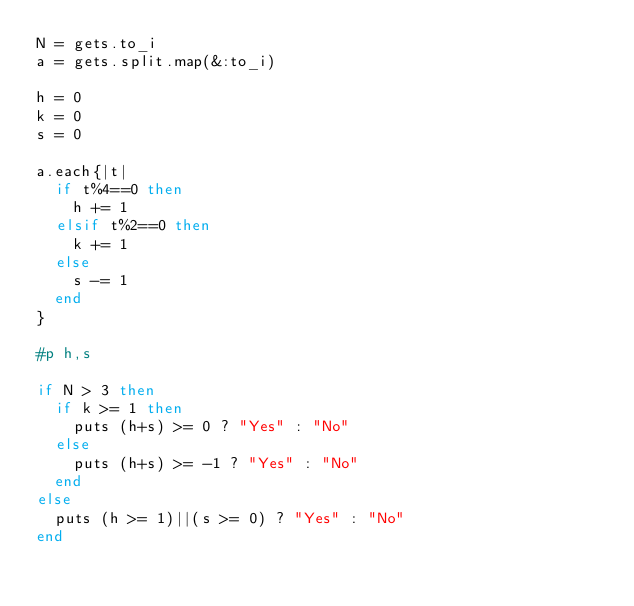Convert code to text. <code><loc_0><loc_0><loc_500><loc_500><_Ruby_>N = gets.to_i
a = gets.split.map(&:to_i)

h = 0
k = 0
s = 0

a.each{|t|
  if t%4==0 then
    h += 1
  elsif t%2==0 then
    k += 1
  else
    s -= 1
  end
}

#p h,s

if N > 3 then 
  if k >= 1 then
    puts (h+s) >= 0 ? "Yes" : "No"
  else
    puts (h+s) >= -1 ? "Yes" : "No"
  end
else
  puts (h >= 1)||(s >= 0) ? "Yes" : "No"
end</code> 